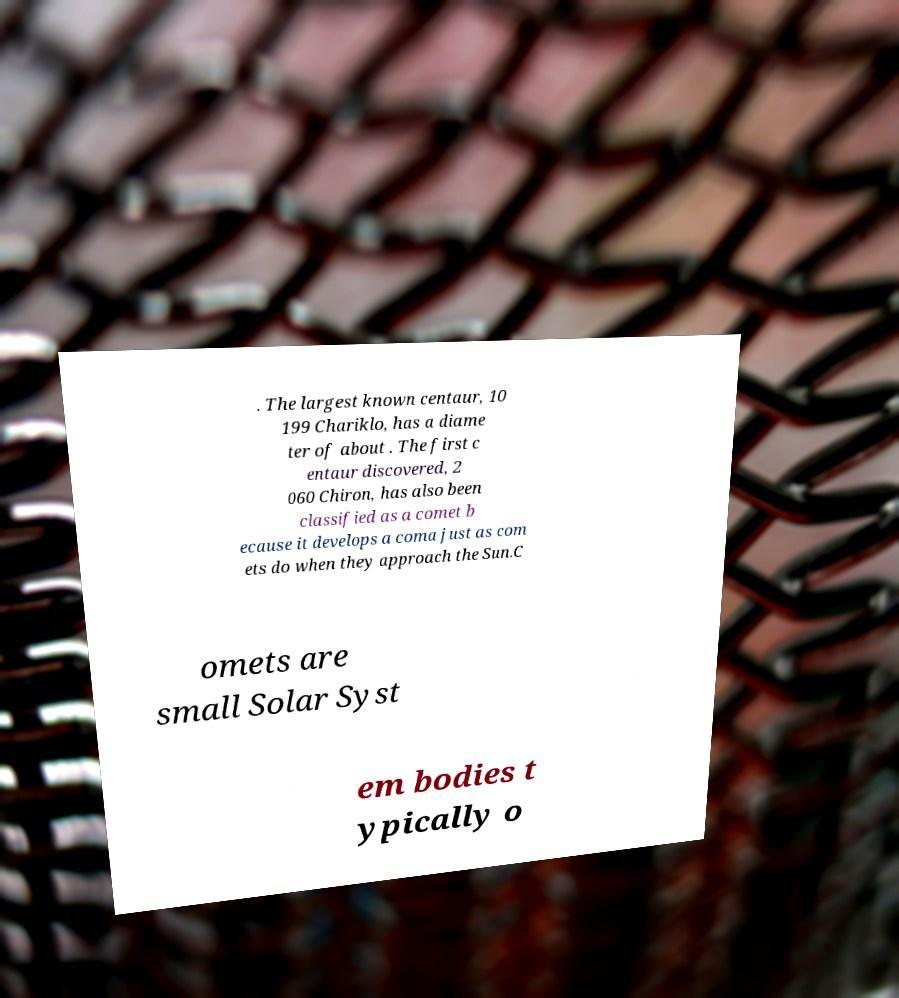What messages or text are displayed in this image? I need them in a readable, typed format. . The largest known centaur, 10 199 Chariklo, has a diame ter of about . The first c entaur discovered, 2 060 Chiron, has also been classified as a comet b ecause it develops a coma just as com ets do when they approach the Sun.C omets are small Solar Syst em bodies t ypically o 